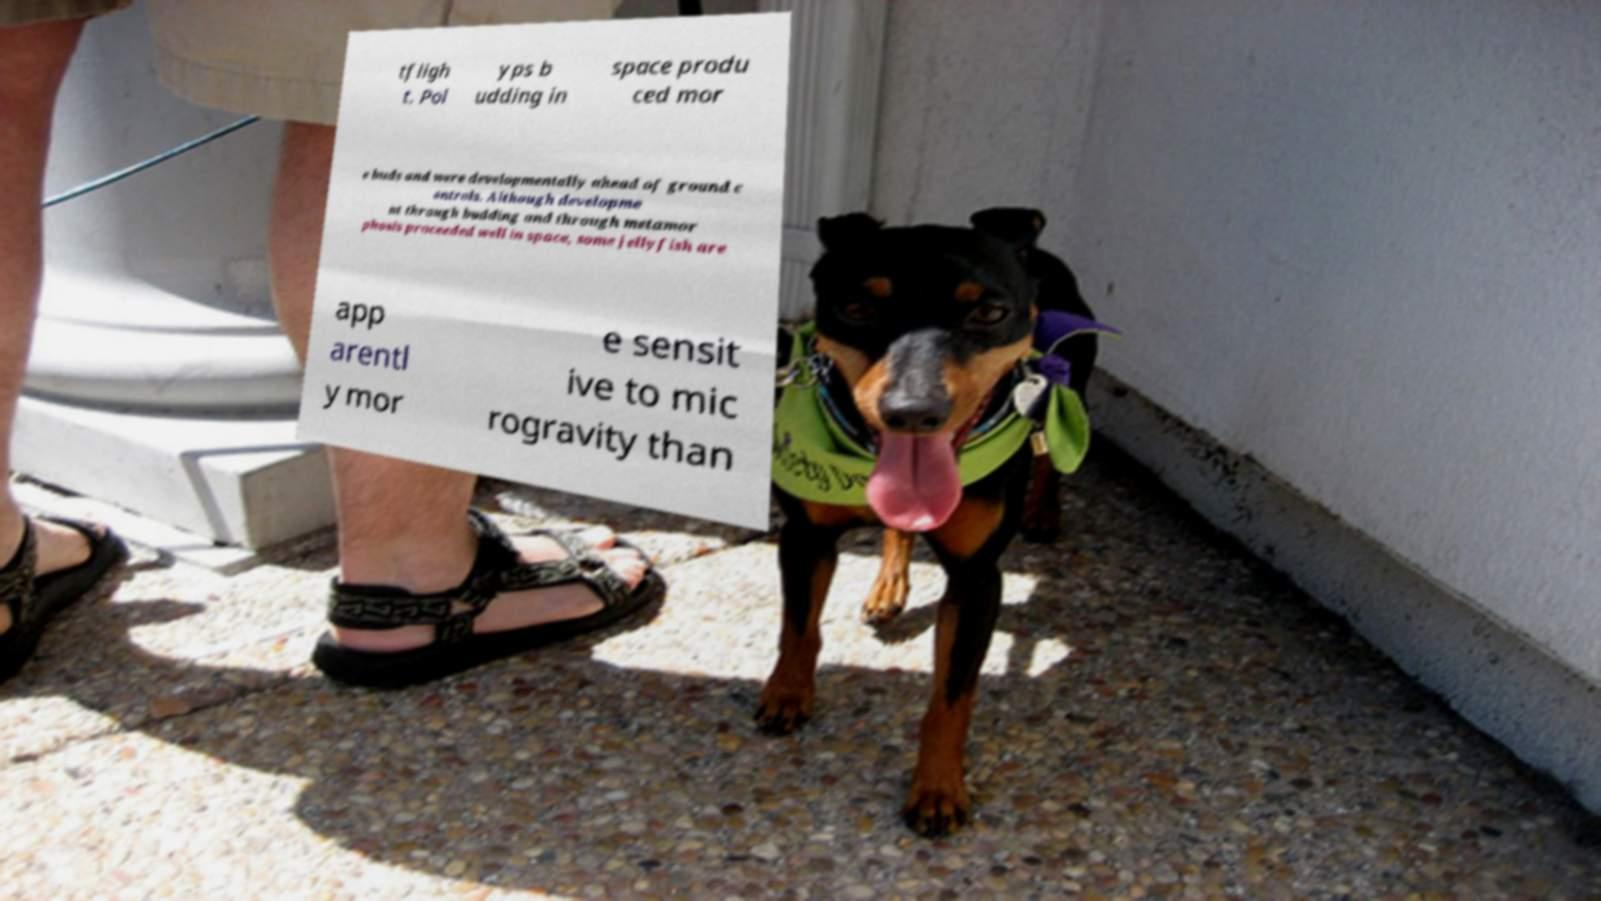Can you accurately transcribe the text from the provided image for me? tfligh t. Pol yps b udding in space produ ced mor e buds and were developmentally ahead of ground c ontrols. Although developme nt through budding and through metamor phosis proceeded well in space, some jellyfish are app arentl y mor e sensit ive to mic rogravity than 